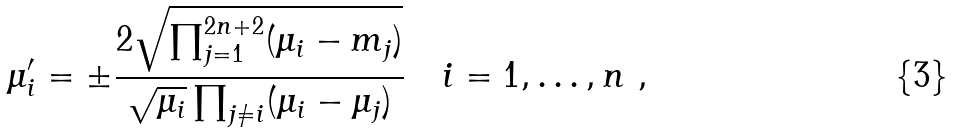Convert formula to latex. <formula><loc_0><loc_0><loc_500><loc_500>\mu _ { i } ^ { \prime } = \pm \frac { 2 \sqrt { \prod _ { j = 1 } ^ { 2 n + 2 } ( \mu _ { i } - m _ { j } ) } } { \sqrt { \mu _ { i } } \prod _ { j \neq i } ( \mu _ { i } - \mu _ { j } ) } \quad i = 1 , \dots , n \ ,</formula> 